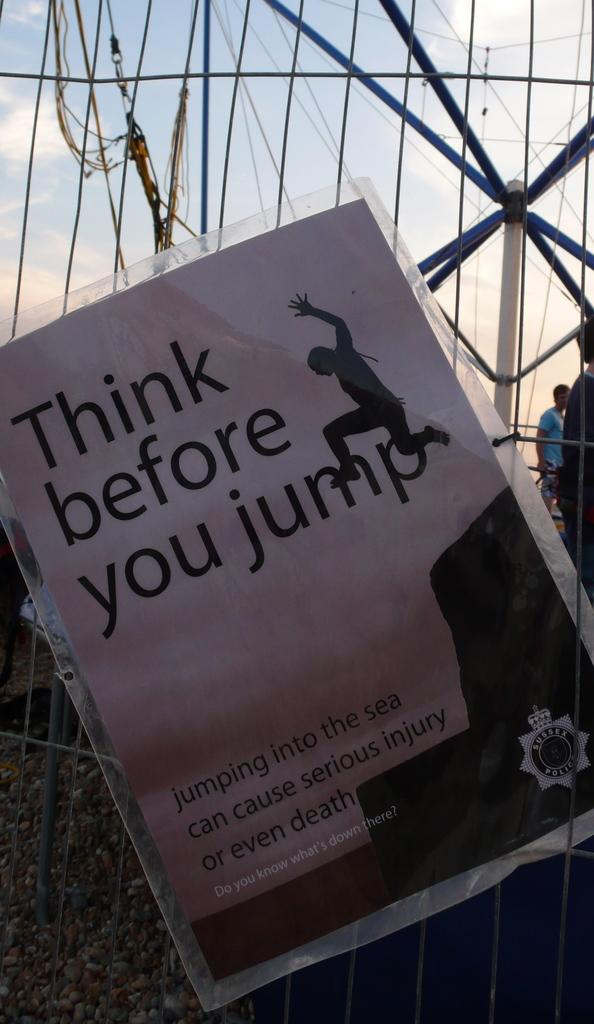What is placed on the fence in the image? There is a paper on the fence in the image. What can be seen in the background of the image? There are people and metal rods in the background of the image. How many deer can be seen in the image? There are no deer present in the image. Is there a cobweb visible on the paper in the image? There is no mention of a cobweb in the image, so it cannot be determined from the provided facts. 